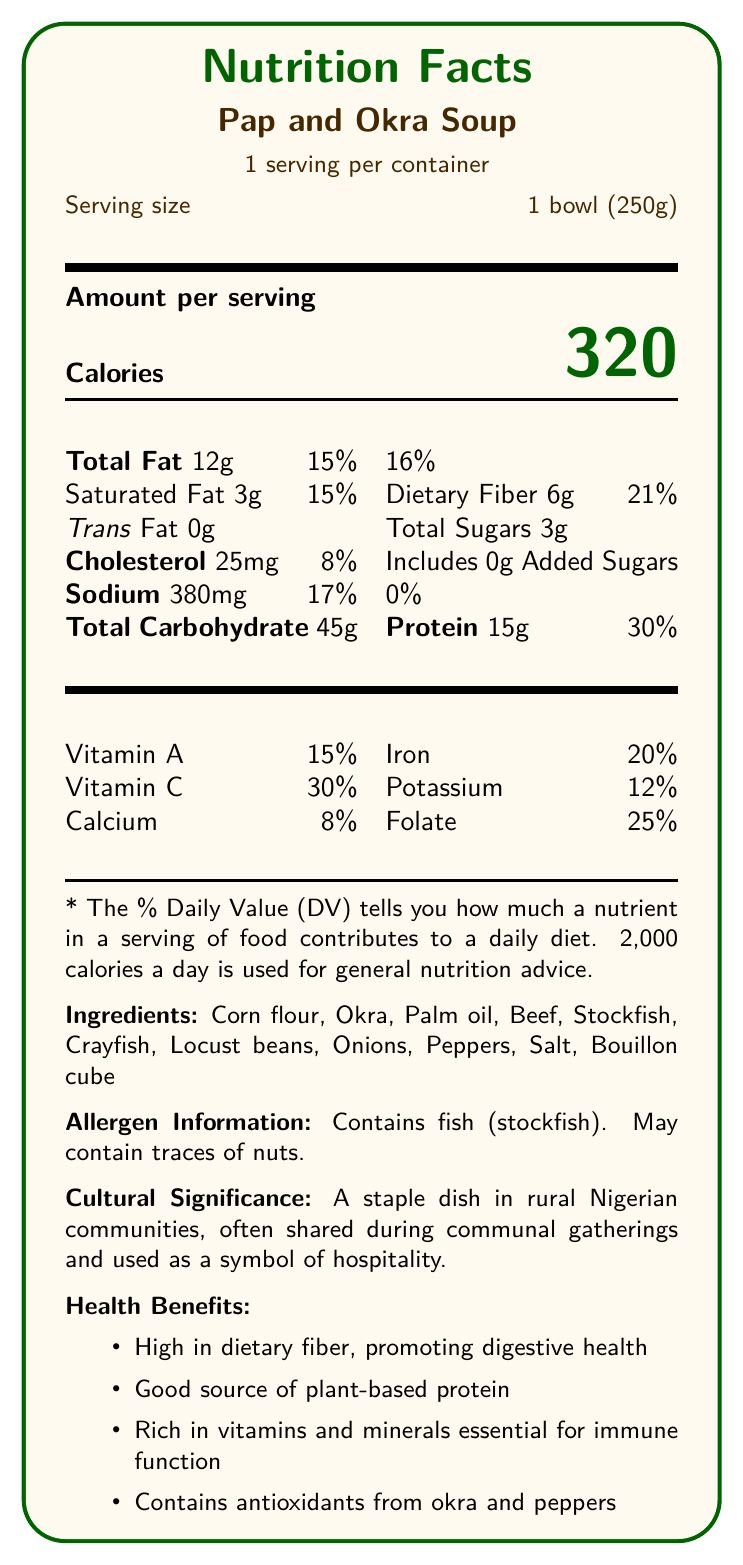what is the serving size of Pap and Okra Soup? The serving size is indicated as "1 bowl (250g)" in the document.
Answer: 1 bowl (250g) how many calories are there per serving? The document specifies that each serving contains 320 calories.
Answer: 320 how much dietary fiber does Pap and Okra Soup contain per serving? The nutrition information states that there are 6 grams of dietary fiber per serving.
Answer: 6g list three ingredients found in Pap and Okra Soup. The ingredients section lists several ingredients, including corn flour, okra, and palm oil.
Answer: Corn flour, Okra, Palm oil what percentage of the daily value for Vitamin C is provided by Pap and Okra Soup? Pap and Okra Soup provides 30% of the daily value for Vitamin C.
Answer: 30% Pap and Okra Soup is high in dietary fiber, promoting which specific health benefit? One of the health benefits listed is that dietary fiber promotes digestive health.
Answer: Digestive health contains fish (stockfish). may contain traces of nuts. The allergen information section states that the dish contains fish (stockfish) and may contain traces of nuts.
Answer: Yes which of the following is not listed as a health benefit of Pap and Okra Soup?
A. Promotes heart health
B. Good source of plant-based protein
C. Rich in vitamins and minerals essential for immune function
D. Contains antioxidants from okra and peppers The health benefits section does not list promoting heart health as a benefit.
Answer: A Pap and Okra Soup supports smallholder farmers through the use of what type of sourced ingredients? 
A. Imported
B. Locally sourced
C. Genetically modified The ethical considerations section mentions that the dish uses locally sourced ingredients.
Answer: B name a vitamin present in Pap and Okra Soup that contributes to immune function. Vitamin C is listed in the nutritional information and is essential for immune function.
Answer: Vitamin C what is the sodium content per serving of Pap and Okra Soup? The nutrition information specifies that there are 380mg of sodium per serving.
Answer: 380mg can Pap and Okra Soup be suitable for a diabetic diet? The medical relevance section mentions that the dish has a moderate glycemic index, making it suitable for controlled portions in diabetic diets.
Answer: Yes summarize the cultural significance and nutritional value of Pap and Okra Soup. The dish is culturally significant in rural Nigerian communities, symbolizing hospitality and communal sharing. Nutritionally, it promotes digestive health, provides plant-based protein, and contains vitamins and minerals important for immune function.
Answer: Pap and Okra Soup is a staple dish in rural Nigerian communities, symbolizing hospitality and is often shared during communal gatherings. Nutritionally, it provides 320 calories per serving, is high in dietary fiber, a good source of plant-based protein, and rich in essential vitamins and minerals. what is the main source of protein in Pap and Okra Soup? The ingredients include beef, which is a primary source of protein in the dish.
Answer: Beef how many total sugars are in a serving of Pap and Okra Soup? The nutrition information states that there are 3 grams of total sugars in a serving.
Answer: 3g how should leftovers of Pap and Okra Soup be stored? The storage instructions advise refrigerating leftovers within 2 hours and consuming them within 3 days.
Answer: Refrigerate within 2 hours of cooking and consume within 3 days is Pap and Okra Soup made with genetically modified ingredients? The document does not provide information regarding whether the ingredients are genetically modified.
Answer: Cannot be determined how does Pap and Okra Soup support cardiovascular health? The medical relevance section states that the dish contains unsaturated fats from palm oil, which are beneficial for cardiovascular health.
Answer: Contains heart-healthy unsaturated fats from palm oil 